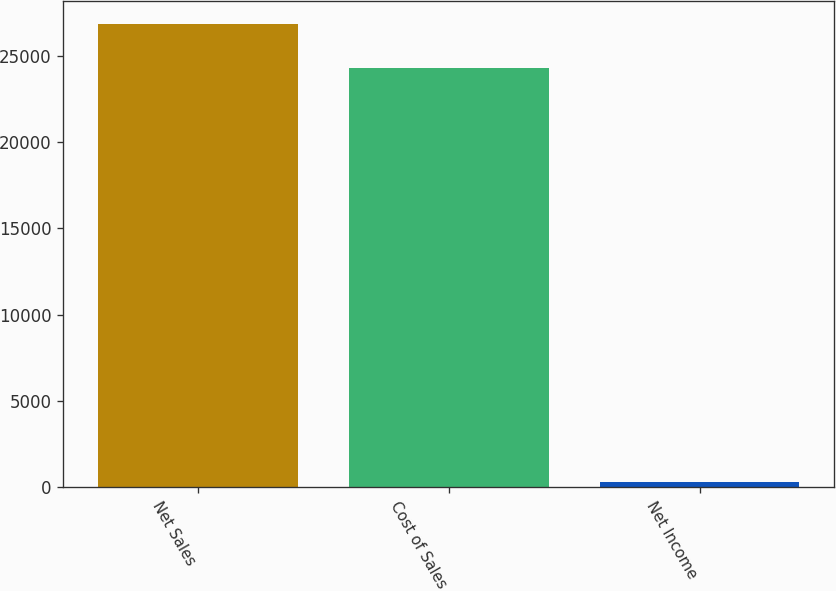Convert chart to OTSL. <chart><loc_0><loc_0><loc_500><loc_500><bar_chart><fcel>Net Sales<fcel>Cost of Sales<fcel>Net Income<nl><fcel>26846.1<fcel>24300<fcel>268<nl></chart> 